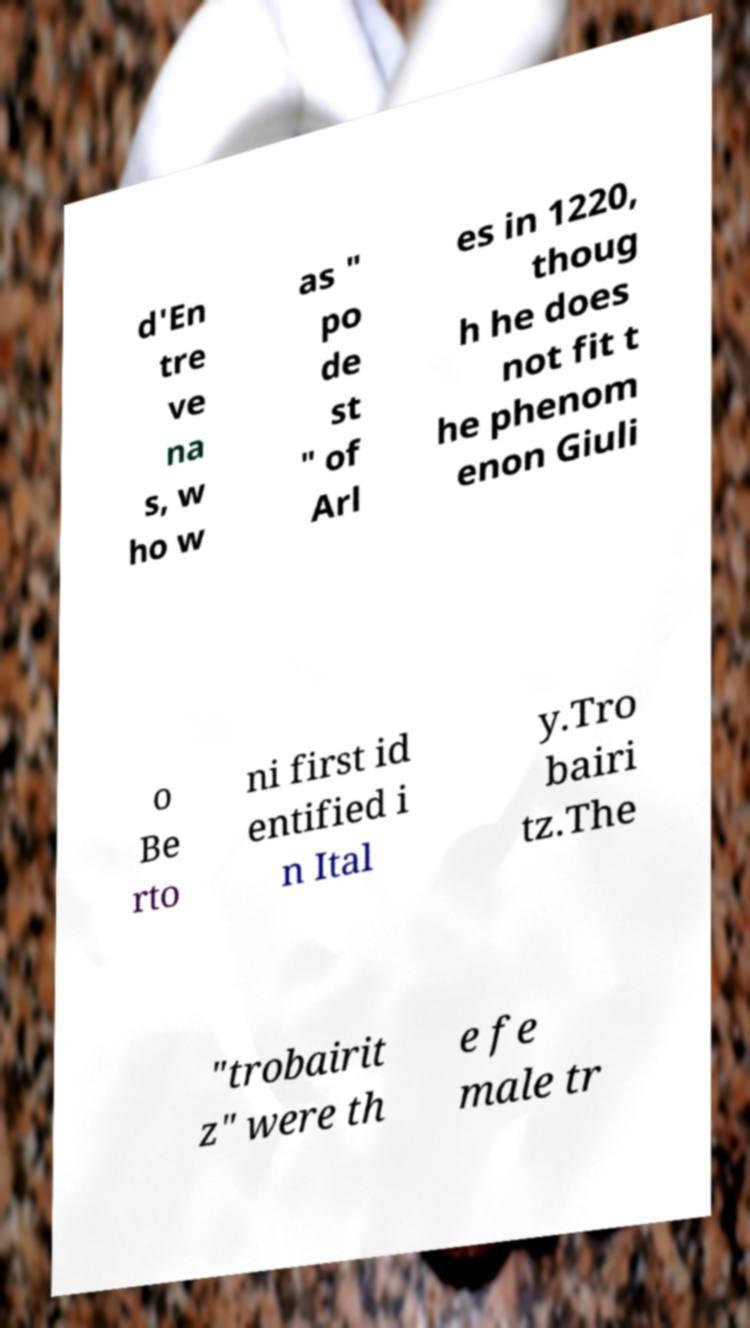Could you assist in decoding the text presented in this image and type it out clearly? d'En tre ve na s, w ho w as " po de st " of Arl es in 1220, thoug h he does not fit t he phenom enon Giuli o Be rto ni first id entified i n Ital y.Tro bairi tz.The "trobairit z" were th e fe male tr 